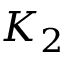<formula> <loc_0><loc_0><loc_500><loc_500>K _ { 2 }</formula> 